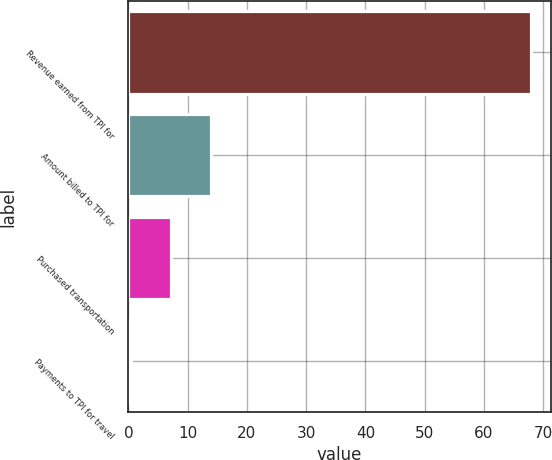Convert chart to OTSL. <chart><loc_0><loc_0><loc_500><loc_500><bar_chart><fcel>Revenue earned from TPI for<fcel>Amount billed to TPI for<fcel>Purchased transportation<fcel>Payments to TPI for travel<nl><fcel>67.9<fcel>13.9<fcel>7.15<fcel>0.4<nl></chart> 